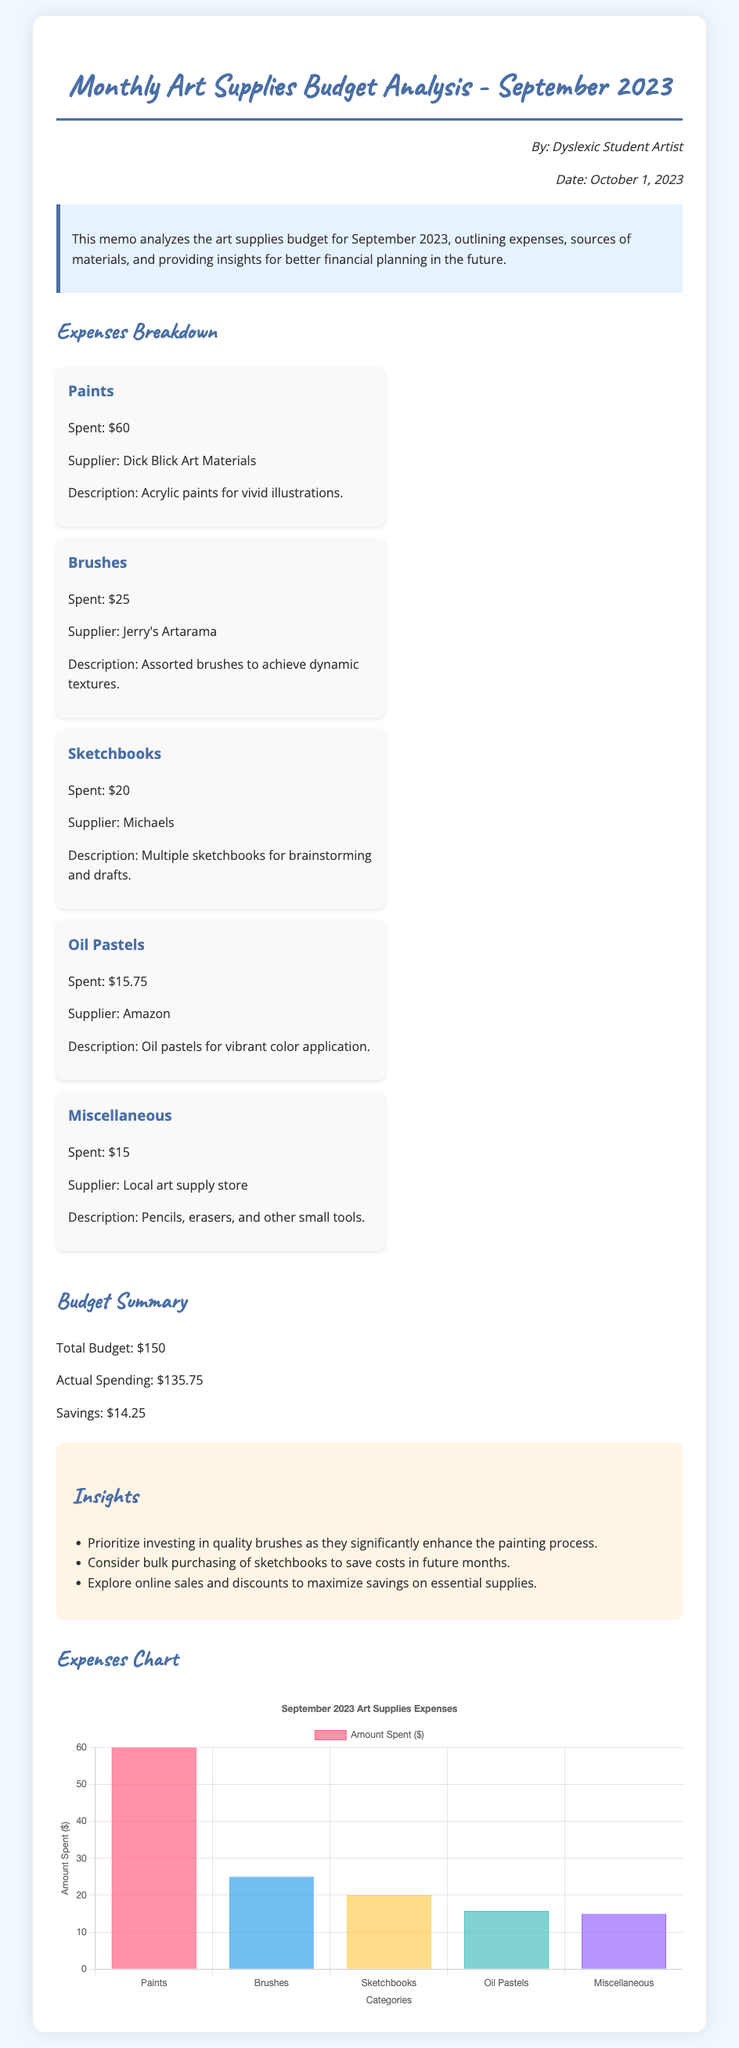What is the total budget? The total budget is indicated in the document as the amount allocated for art supplies in September 2023.
Answer: $150 Who is the author of the memo? The author's name is mentioned at the top of the memo, giving credit to the individual who created it.
Answer: Dyslexic Student Artist What is the amount spent on brushes? This information can be found in the expenses breakdown section detailing specific supplies and their costs.
Answer: $25 What is the savings achieved for the month? The savings is calculated as the difference between the total budget and actual spending, shown in the budget summary section.
Answer: $14.25 How much was spent on oil pastels? The spending on oil pastels is noted in the expenses breakdown as part of the individual item costs.
Answer: $15.75 What supplier provided the paints? The supplier is given in the expense item about paints, detailing where they were purchased from.
Answer: Dick Blick Art Materials What category spent the most? This question requires analyzing the expenses and identifying which item had the highest cost.
Answer: Paints What is one insight regarding future purchases? Insights provided aim to suggest improvements for future financial planning based on the analysis in the memo.
Answer: Prioritize investing in quality brushes How many categories of expenses are listed? The memo includes specific items for expenses, quantifying the amount of distinct categories mentioned.
Answer: 5 